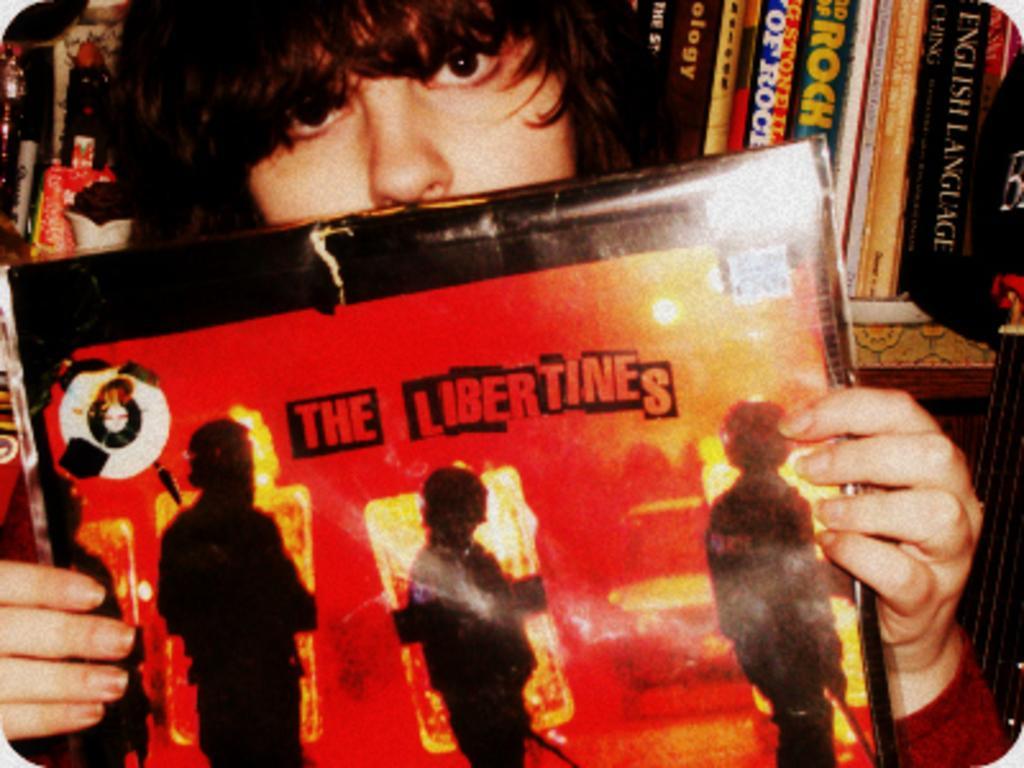Please provide a concise description of this image. In this image, we can see a person holding a board with his hands. There are books in the top right of the image. 